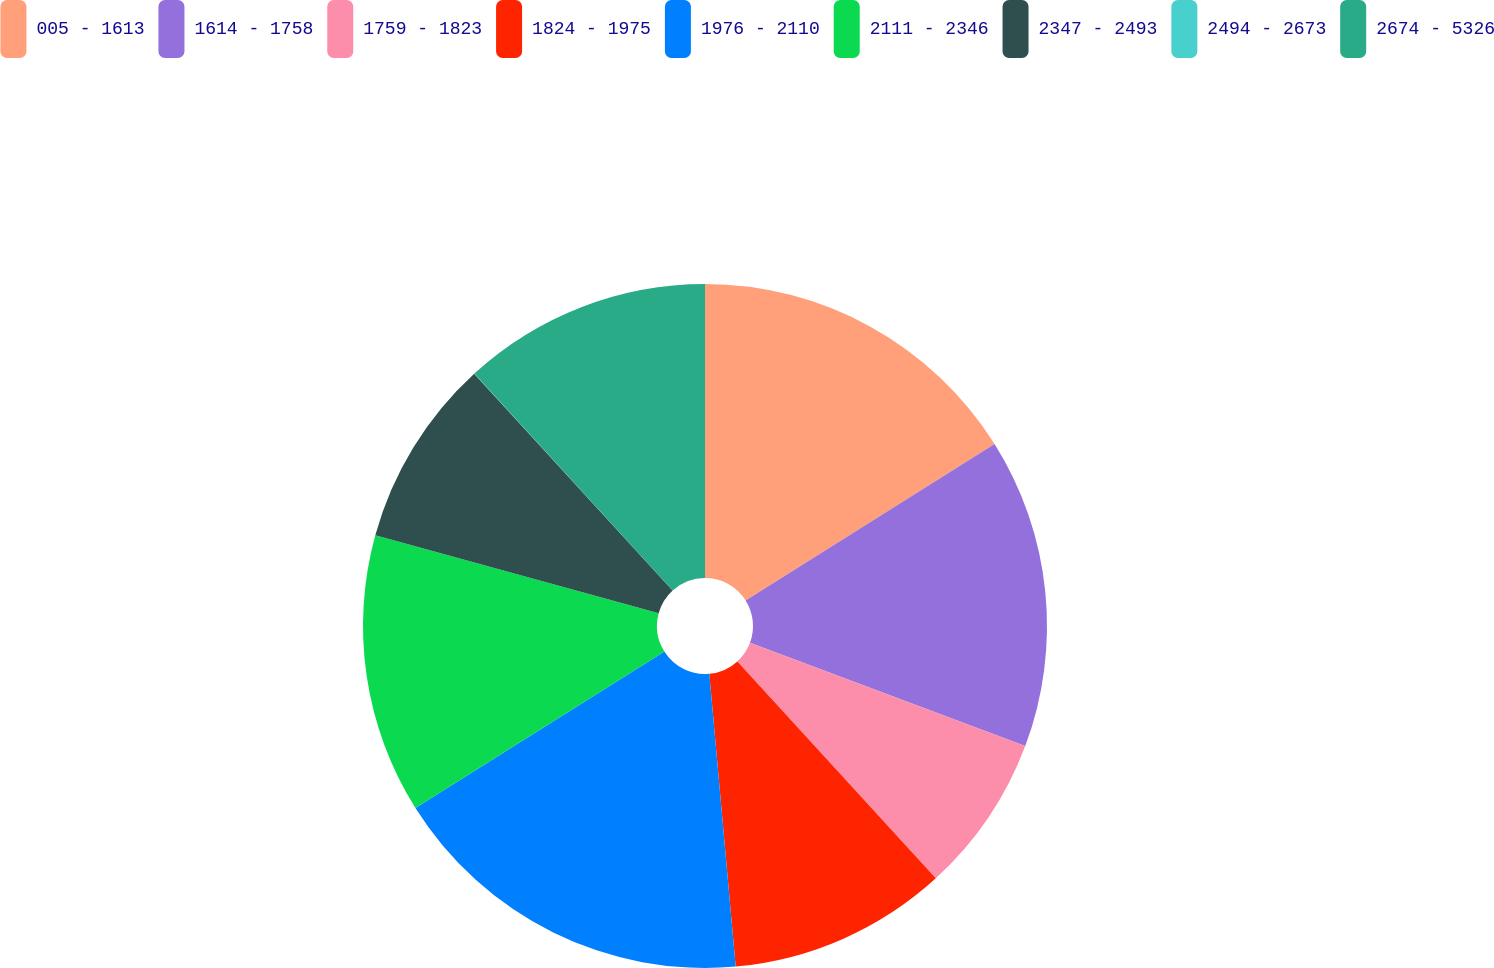Convert chart to OTSL. <chart><loc_0><loc_0><loc_500><loc_500><pie_chart><fcel>005 - 1613<fcel>1614 - 1758<fcel>1759 - 1823<fcel>1824 - 1975<fcel>1976 - 2110<fcel>2111 - 2346<fcel>2347 - 2493<fcel>2494 - 2673<fcel>2674 - 5326<nl><fcel>16.07%<fcel>14.64%<fcel>7.5%<fcel>10.36%<fcel>17.5%<fcel>13.21%<fcel>8.93%<fcel>0.01%<fcel>11.78%<nl></chart> 